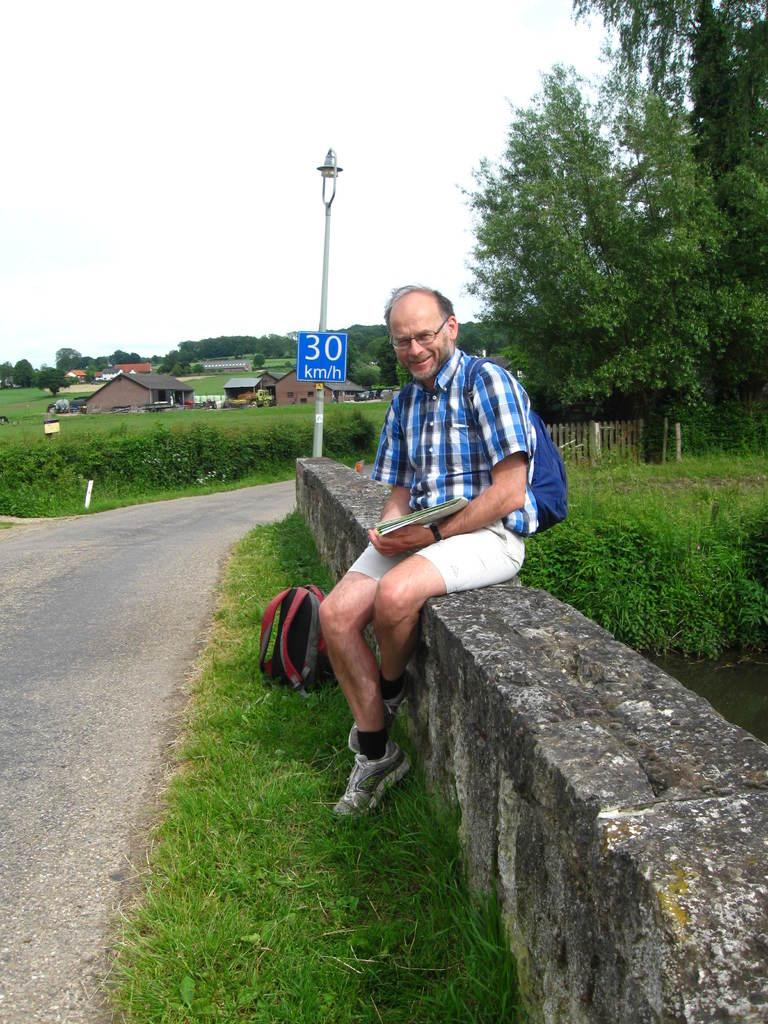<image>
Summarize the visual content of the image. A man sits on a stone wall in front of a blue speed sign of 30 kph. 